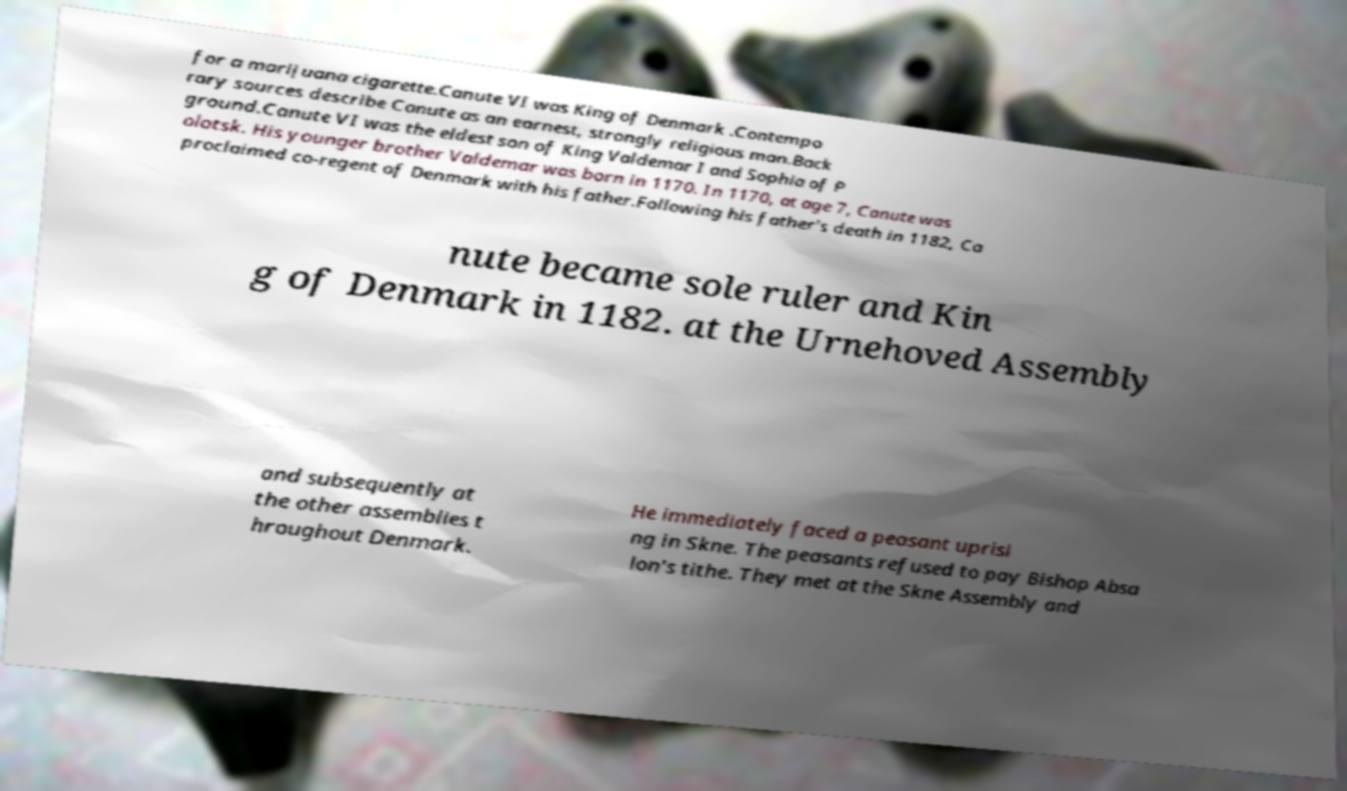Please read and relay the text visible in this image. What does it say? for a marijuana cigarette.Canute VI was King of Denmark .Contempo rary sources describe Canute as an earnest, strongly religious man.Back ground.Canute VI was the eldest son of King Valdemar I and Sophia of P olotsk. His younger brother Valdemar was born in 1170. In 1170, at age 7, Canute was proclaimed co-regent of Denmark with his father.Following his father's death in 1182, Ca nute became sole ruler and Kin g of Denmark in 1182. at the Urnehoved Assembly and subsequently at the other assemblies t hroughout Denmark. He immediately faced a peasant uprisi ng in Skne. The peasants refused to pay Bishop Absa lon's tithe. They met at the Skne Assembly and 